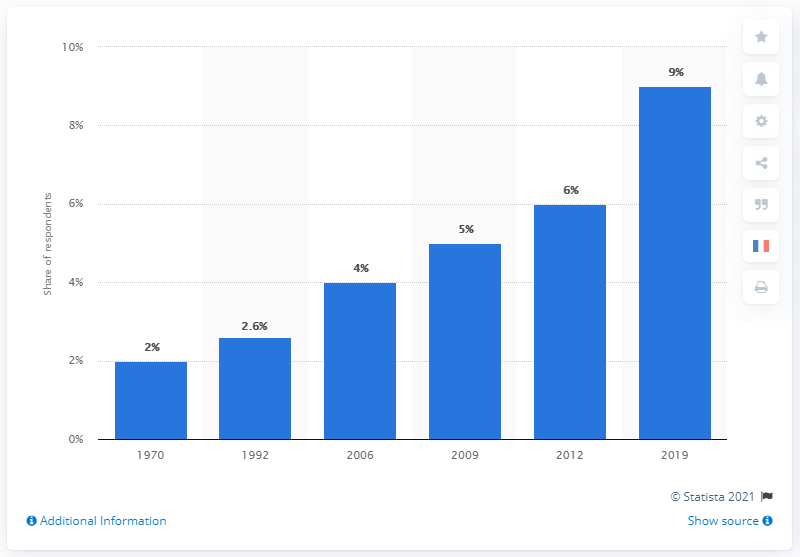Indicate a few pertinent items in this graphic. For how long is the proportion over 5%? The chart reached its peak in 2019. 